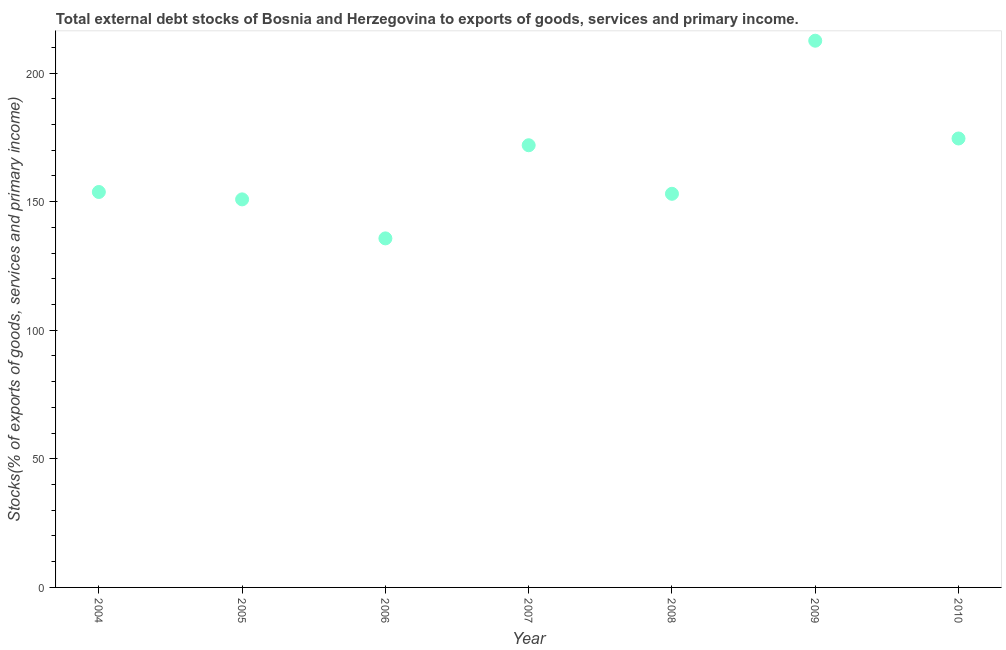What is the external debt stocks in 2005?
Provide a short and direct response. 150.89. Across all years, what is the maximum external debt stocks?
Offer a very short reply. 212.59. Across all years, what is the minimum external debt stocks?
Provide a short and direct response. 135.72. In which year was the external debt stocks maximum?
Ensure brevity in your answer.  2009. What is the sum of the external debt stocks?
Provide a short and direct response. 1152.55. What is the difference between the external debt stocks in 2005 and 2006?
Your answer should be very brief. 15.17. What is the average external debt stocks per year?
Give a very brief answer. 164.65. What is the median external debt stocks?
Ensure brevity in your answer.  153.77. Do a majority of the years between 2010 and 2004 (inclusive) have external debt stocks greater than 90 %?
Your response must be concise. Yes. What is the ratio of the external debt stocks in 2006 to that in 2008?
Your response must be concise. 0.89. Is the difference between the external debt stocks in 2005 and 2006 greater than the difference between any two years?
Provide a succinct answer. No. What is the difference between the highest and the second highest external debt stocks?
Your answer should be compact. 38.02. What is the difference between the highest and the lowest external debt stocks?
Make the answer very short. 76.87. In how many years, is the external debt stocks greater than the average external debt stocks taken over all years?
Your answer should be very brief. 3. Does the external debt stocks monotonically increase over the years?
Make the answer very short. No. Does the graph contain grids?
Provide a short and direct response. No. What is the title of the graph?
Offer a terse response. Total external debt stocks of Bosnia and Herzegovina to exports of goods, services and primary income. What is the label or title of the Y-axis?
Provide a succinct answer. Stocks(% of exports of goods, services and primary income). What is the Stocks(% of exports of goods, services and primary income) in 2004?
Your answer should be very brief. 153.77. What is the Stocks(% of exports of goods, services and primary income) in 2005?
Give a very brief answer. 150.89. What is the Stocks(% of exports of goods, services and primary income) in 2006?
Give a very brief answer. 135.72. What is the Stocks(% of exports of goods, services and primary income) in 2007?
Your response must be concise. 171.94. What is the Stocks(% of exports of goods, services and primary income) in 2008?
Ensure brevity in your answer.  153.06. What is the Stocks(% of exports of goods, services and primary income) in 2009?
Your response must be concise. 212.59. What is the Stocks(% of exports of goods, services and primary income) in 2010?
Make the answer very short. 174.57. What is the difference between the Stocks(% of exports of goods, services and primary income) in 2004 and 2005?
Your answer should be very brief. 2.87. What is the difference between the Stocks(% of exports of goods, services and primary income) in 2004 and 2006?
Offer a terse response. 18.04. What is the difference between the Stocks(% of exports of goods, services and primary income) in 2004 and 2007?
Provide a succinct answer. -18.18. What is the difference between the Stocks(% of exports of goods, services and primary income) in 2004 and 2008?
Your answer should be very brief. 0.7. What is the difference between the Stocks(% of exports of goods, services and primary income) in 2004 and 2009?
Ensure brevity in your answer.  -58.82. What is the difference between the Stocks(% of exports of goods, services and primary income) in 2004 and 2010?
Provide a succinct answer. -20.8. What is the difference between the Stocks(% of exports of goods, services and primary income) in 2005 and 2006?
Ensure brevity in your answer.  15.17. What is the difference between the Stocks(% of exports of goods, services and primary income) in 2005 and 2007?
Offer a terse response. -21.05. What is the difference between the Stocks(% of exports of goods, services and primary income) in 2005 and 2008?
Offer a terse response. -2.17. What is the difference between the Stocks(% of exports of goods, services and primary income) in 2005 and 2009?
Offer a terse response. -61.7. What is the difference between the Stocks(% of exports of goods, services and primary income) in 2005 and 2010?
Ensure brevity in your answer.  -23.68. What is the difference between the Stocks(% of exports of goods, services and primary income) in 2006 and 2007?
Make the answer very short. -36.22. What is the difference between the Stocks(% of exports of goods, services and primary income) in 2006 and 2008?
Give a very brief answer. -17.34. What is the difference between the Stocks(% of exports of goods, services and primary income) in 2006 and 2009?
Provide a short and direct response. -76.87. What is the difference between the Stocks(% of exports of goods, services and primary income) in 2006 and 2010?
Your answer should be compact. -38.85. What is the difference between the Stocks(% of exports of goods, services and primary income) in 2007 and 2008?
Provide a short and direct response. 18.88. What is the difference between the Stocks(% of exports of goods, services and primary income) in 2007 and 2009?
Offer a terse response. -40.65. What is the difference between the Stocks(% of exports of goods, services and primary income) in 2007 and 2010?
Provide a short and direct response. -2.63. What is the difference between the Stocks(% of exports of goods, services and primary income) in 2008 and 2009?
Ensure brevity in your answer.  -59.53. What is the difference between the Stocks(% of exports of goods, services and primary income) in 2008 and 2010?
Keep it short and to the point. -21.51. What is the difference between the Stocks(% of exports of goods, services and primary income) in 2009 and 2010?
Provide a short and direct response. 38.02. What is the ratio of the Stocks(% of exports of goods, services and primary income) in 2004 to that in 2006?
Your answer should be very brief. 1.13. What is the ratio of the Stocks(% of exports of goods, services and primary income) in 2004 to that in 2007?
Offer a terse response. 0.89. What is the ratio of the Stocks(% of exports of goods, services and primary income) in 2004 to that in 2009?
Your answer should be very brief. 0.72. What is the ratio of the Stocks(% of exports of goods, services and primary income) in 2004 to that in 2010?
Make the answer very short. 0.88. What is the ratio of the Stocks(% of exports of goods, services and primary income) in 2005 to that in 2006?
Your response must be concise. 1.11. What is the ratio of the Stocks(% of exports of goods, services and primary income) in 2005 to that in 2007?
Your answer should be compact. 0.88. What is the ratio of the Stocks(% of exports of goods, services and primary income) in 2005 to that in 2008?
Provide a short and direct response. 0.99. What is the ratio of the Stocks(% of exports of goods, services and primary income) in 2005 to that in 2009?
Your answer should be very brief. 0.71. What is the ratio of the Stocks(% of exports of goods, services and primary income) in 2005 to that in 2010?
Offer a terse response. 0.86. What is the ratio of the Stocks(% of exports of goods, services and primary income) in 2006 to that in 2007?
Keep it short and to the point. 0.79. What is the ratio of the Stocks(% of exports of goods, services and primary income) in 2006 to that in 2008?
Give a very brief answer. 0.89. What is the ratio of the Stocks(% of exports of goods, services and primary income) in 2006 to that in 2009?
Your answer should be compact. 0.64. What is the ratio of the Stocks(% of exports of goods, services and primary income) in 2006 to that in 2010?
Ensure brevity in your answer.  0.78. What is the ratio of the Stocks(% of exports of goods, services and primary income) in 2007 to that in 2008?
Make the answer very short. 1.12. What is the ratio of the Stocks(% of exports of goods, services and primary income) in 2007 to that in 2009?
Your answer should be very brief. 0.81. What is the ratio of the Stocks(% of exports of goods, services and primary income) in 2008 to that in 2009?
Your response must be concise. 0.72. What is the ratio of the Stocks(% of exports of goods, services and primary income) in 2008 to that in 2010?
Ensure brevity in your answer.  0.88. What is the ratio of the Stocks(% of exports of goods, services and primary income) in 2009 to that in 2010?
Ensure brevity in your answer.  1.22. 